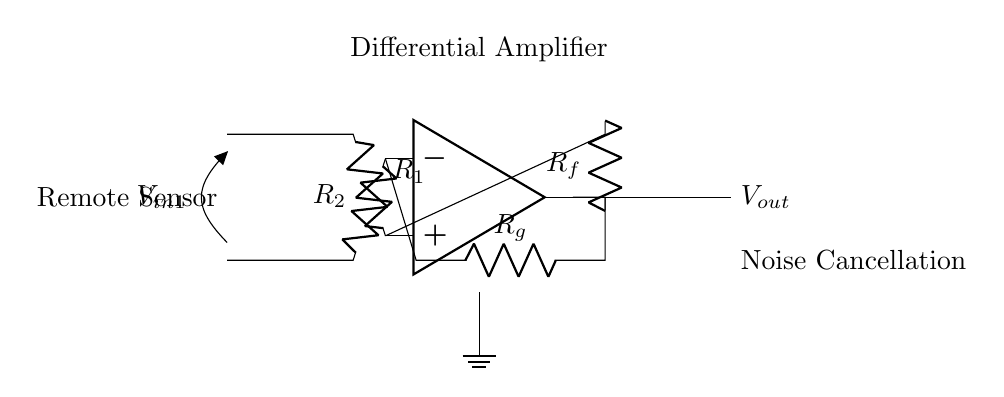What is the role of the operational amplifier in this circuit? The operational amplifier amplifies the difference between the two input voltages, which is key for noise cancellation in this application.
Answer: Amplification What components are used as input resistors? The two input resistors are represented as R1 and R2 in the circuit, connected to the positive and negative inputs of the operational amplifier.
Answer: R1 and R2 What is the output voltage denoted as in the circuit? The output voltage of the circuit is indicated at the right side as Vout, which results from the amplification process based on the input differential voltage.
Answer: Vout Which component is responsible for feedback in this circuit? The feedback in this differential amplifier circuit is provided by the resistor labeled Rf, which connects the output back to the positive input of the operational amplifier.
Answer: Rf How can noise cancellation be achieved using this differential amplifier? The differential amplifier subtracts the noise component present in both input signals, allowing cancellation of common-mode noise, enhancing signal integrity in remote sensing applications.
Answer: By subtraction What is the relationship between Rg and the gain of the amplifier? The gain of the amplifier is influenced by the resistor Rg in the feedback loop, determining how much the amplified output signal responds to changes in the input differential signal.
Answer: Gain relationship 